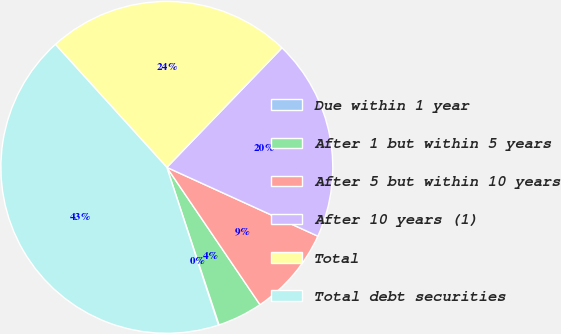Convert chart. <chart><loc_0><loc_0><loc_500><loc_500><pie_chart><fcel>Due within 1 year<fcel>After 1 but within 5 years<fcel>After 5 but within 10 years<fcel>After 10 years (1)<fcel>Total<fcel>Total debt securities<nl><fcel>0.06%<fcel>4.39%<fcel>8.71%<fcel>19.6%<fcel>23.92%<fcel>43.32%<nl></chart> 